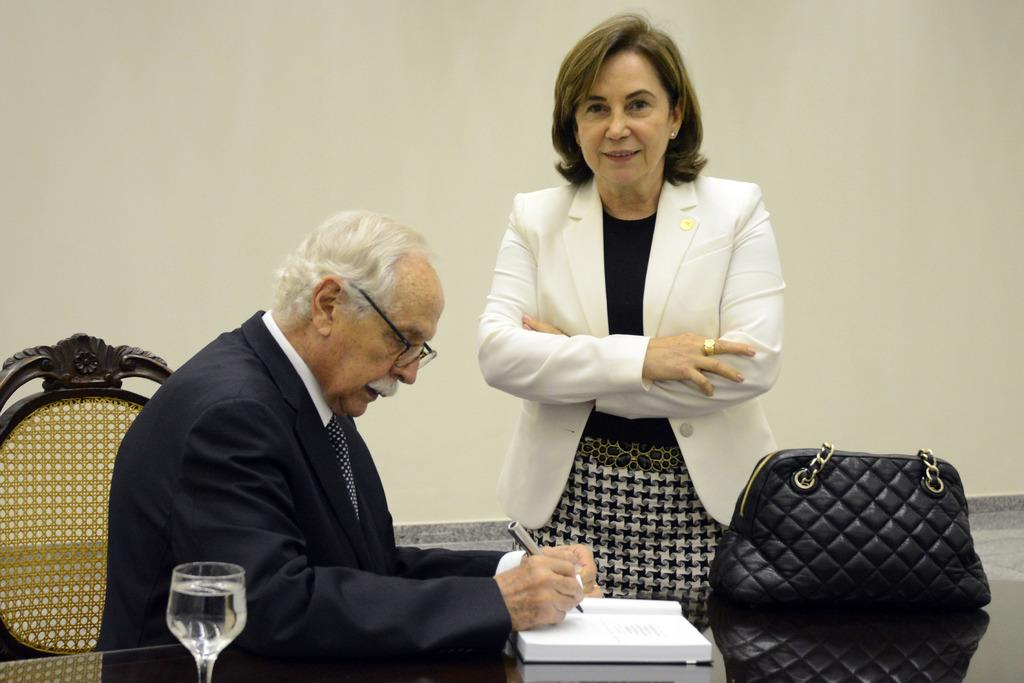What is the person in the image wearing? The person is wearing a black suit in the image. What is the person doing while wearing the suit? The person is writing in a book. Where is the book located? The book is on a table. Who is beside the person writing in the book? There is a lady beside the person. What item is near the lady? The lady has a handbag beside her. What type of lock is on the desk in the image? There is no desk present in the image, and therefore no lock can be observed. 